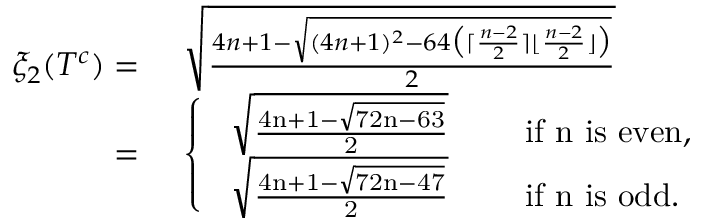<formula> <loc_0><loc_0><loc_500><loc_500>\begin{array} { r l } { \xi _ { 2 } ( T ^ { c } ) = } & { \sqrt { \frac { 4 n + 1 - \sqrt { ( 4 n + 1 ) ^ { 2 } - 6 4 \left ( \lceil \frac { n - 2 } { 2 } \rceil \lfloor \frac { n - 2 } { 2 } \rfloor \right ) } } { 2 } } } \\ { = } & { \left \{ \begin{array} { l l } { \sqrt { \frac { 4 n + 1 - \sqrt { 7 2 n - 6 3 } } { 2 } } } & { \quad i f n i s e v e n , } \\ { \sqrt { \frac { 4 n + 1 - \sqrt { 7 2 n - 4 7 } } { 2 } } } & { \quad i f n i s o d d . } \end{array} } \end{array}</formula> 